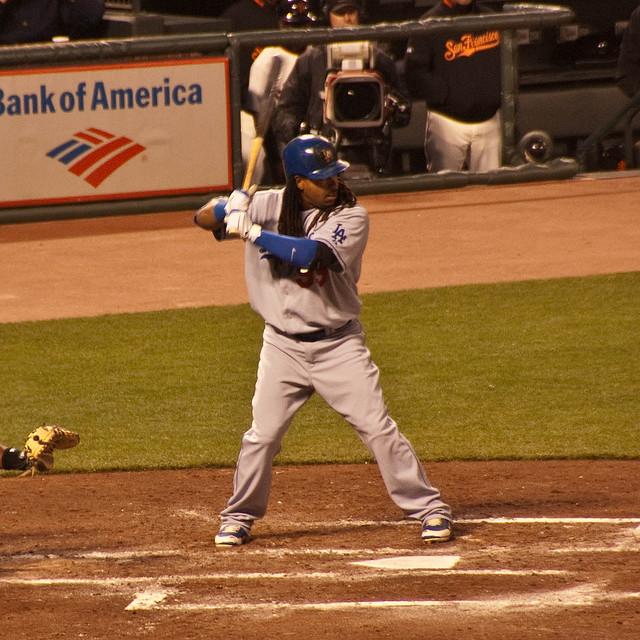What Bank is advertised here?
Be succinct. Bank of america. What part of the catcher can be seen?
Give a very brief answer. Hand. What baseball team is at bat?
Give a very brief answer. La. 